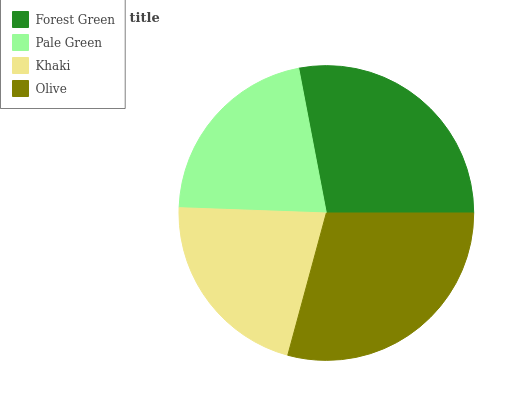Is Khaki the minimum?
Answer yes or no. Yes. Is Olive the maximum?
Answer yes or no. Yes. Is Pale Green the minimum?
Answer yes or no. No. Is Pale Green the maximum?
Answer yes or no. No. Is Forest Green greater than Pale Green?
Answer yes or no. Yes. Is Pale Green less than Forest Green?
Answer yes or no. Yes. Is Pale Green greater than Forest Green?
Answer yes or no. No. Is Forest Green less than Pale Green?
Answer yes or no. No. Is Forest Green the high median?
Answer yes or no. Yes. Is Pale Green the low median?
Answer yes or no. Yes. Is Khaki the high median?
Answer yes or no. No. Is Forest Green the low median?
Answer yes or no. No. 